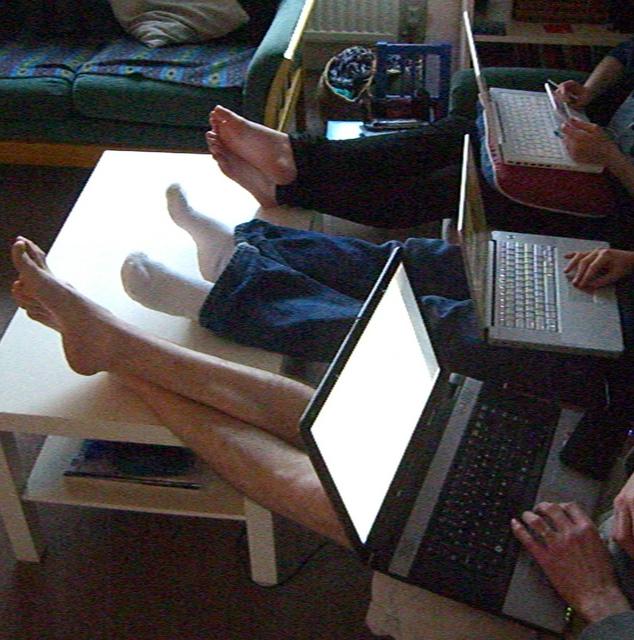Are the people in the picture wearing shoes?
Answer briefly. No. Which person Is the tallest?
Quick response, please. Closest to camera. How many people are wearing socks?
Be succinct. 1. 